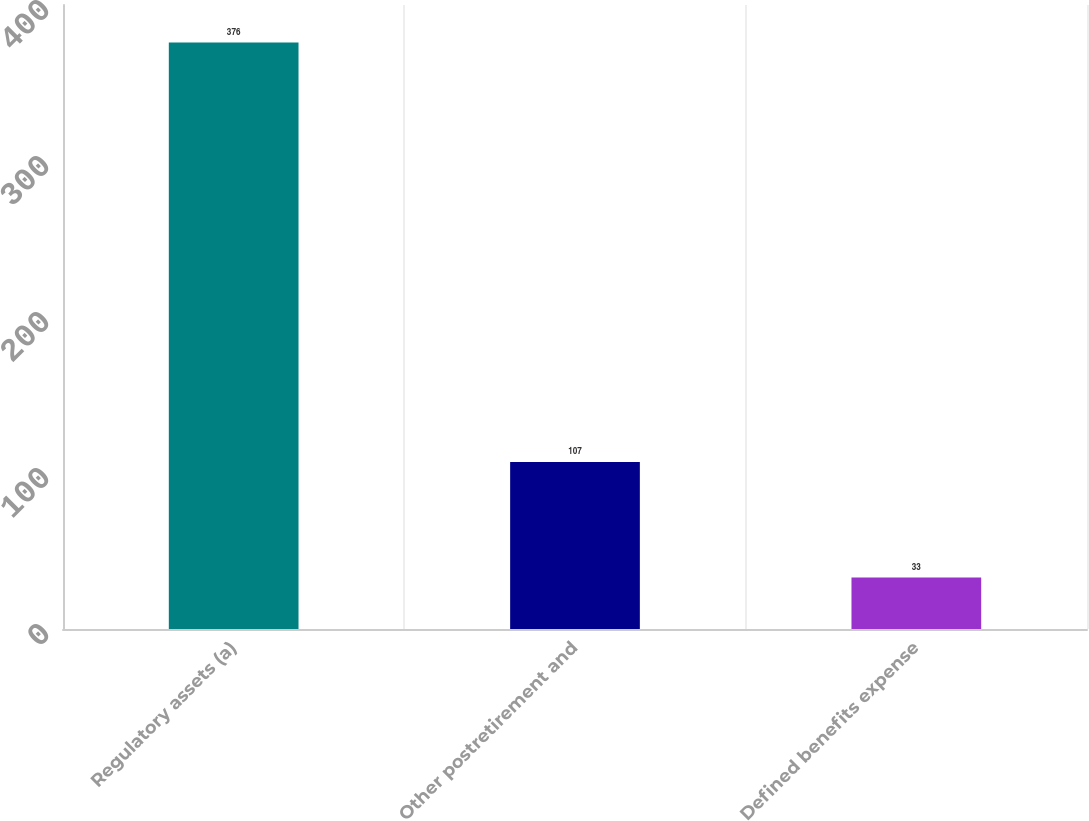<chart> <loc_0><loc_0><loc_500><loc_500><bar_chart><fcel>Regulatory assets (a)<fcel>Other postretirement and<fcel>Defined benefits expense<nl><fcel>376<fcel>107<fcel>33<nl></chart> 